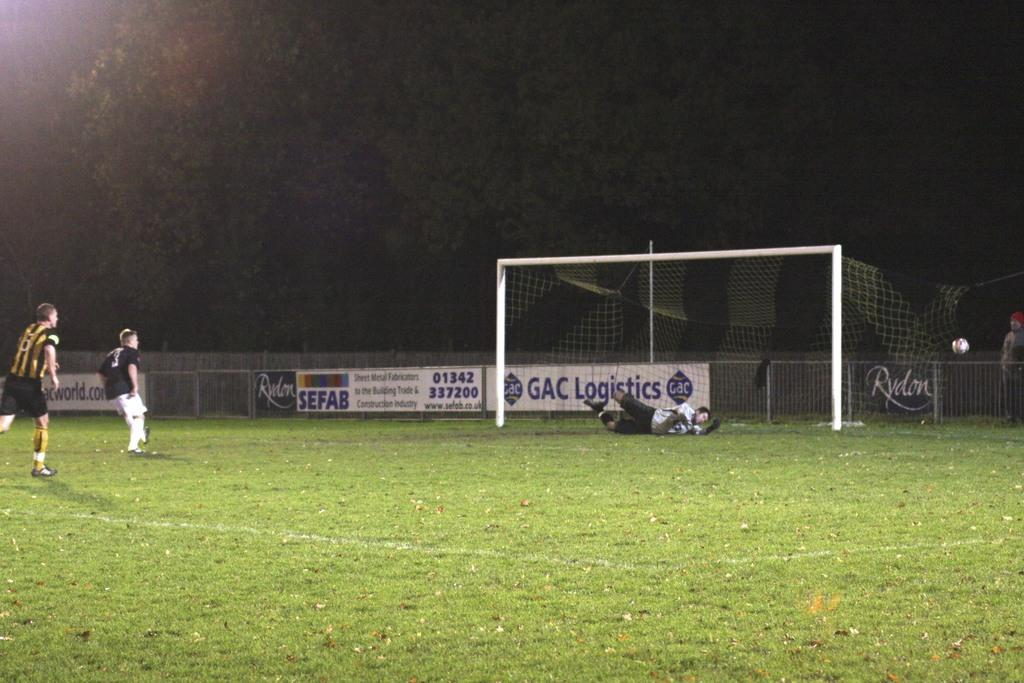<image>
Render a clear and concise summary of the photo. Three people on a soccer field with a banner that says GAC Logistics 